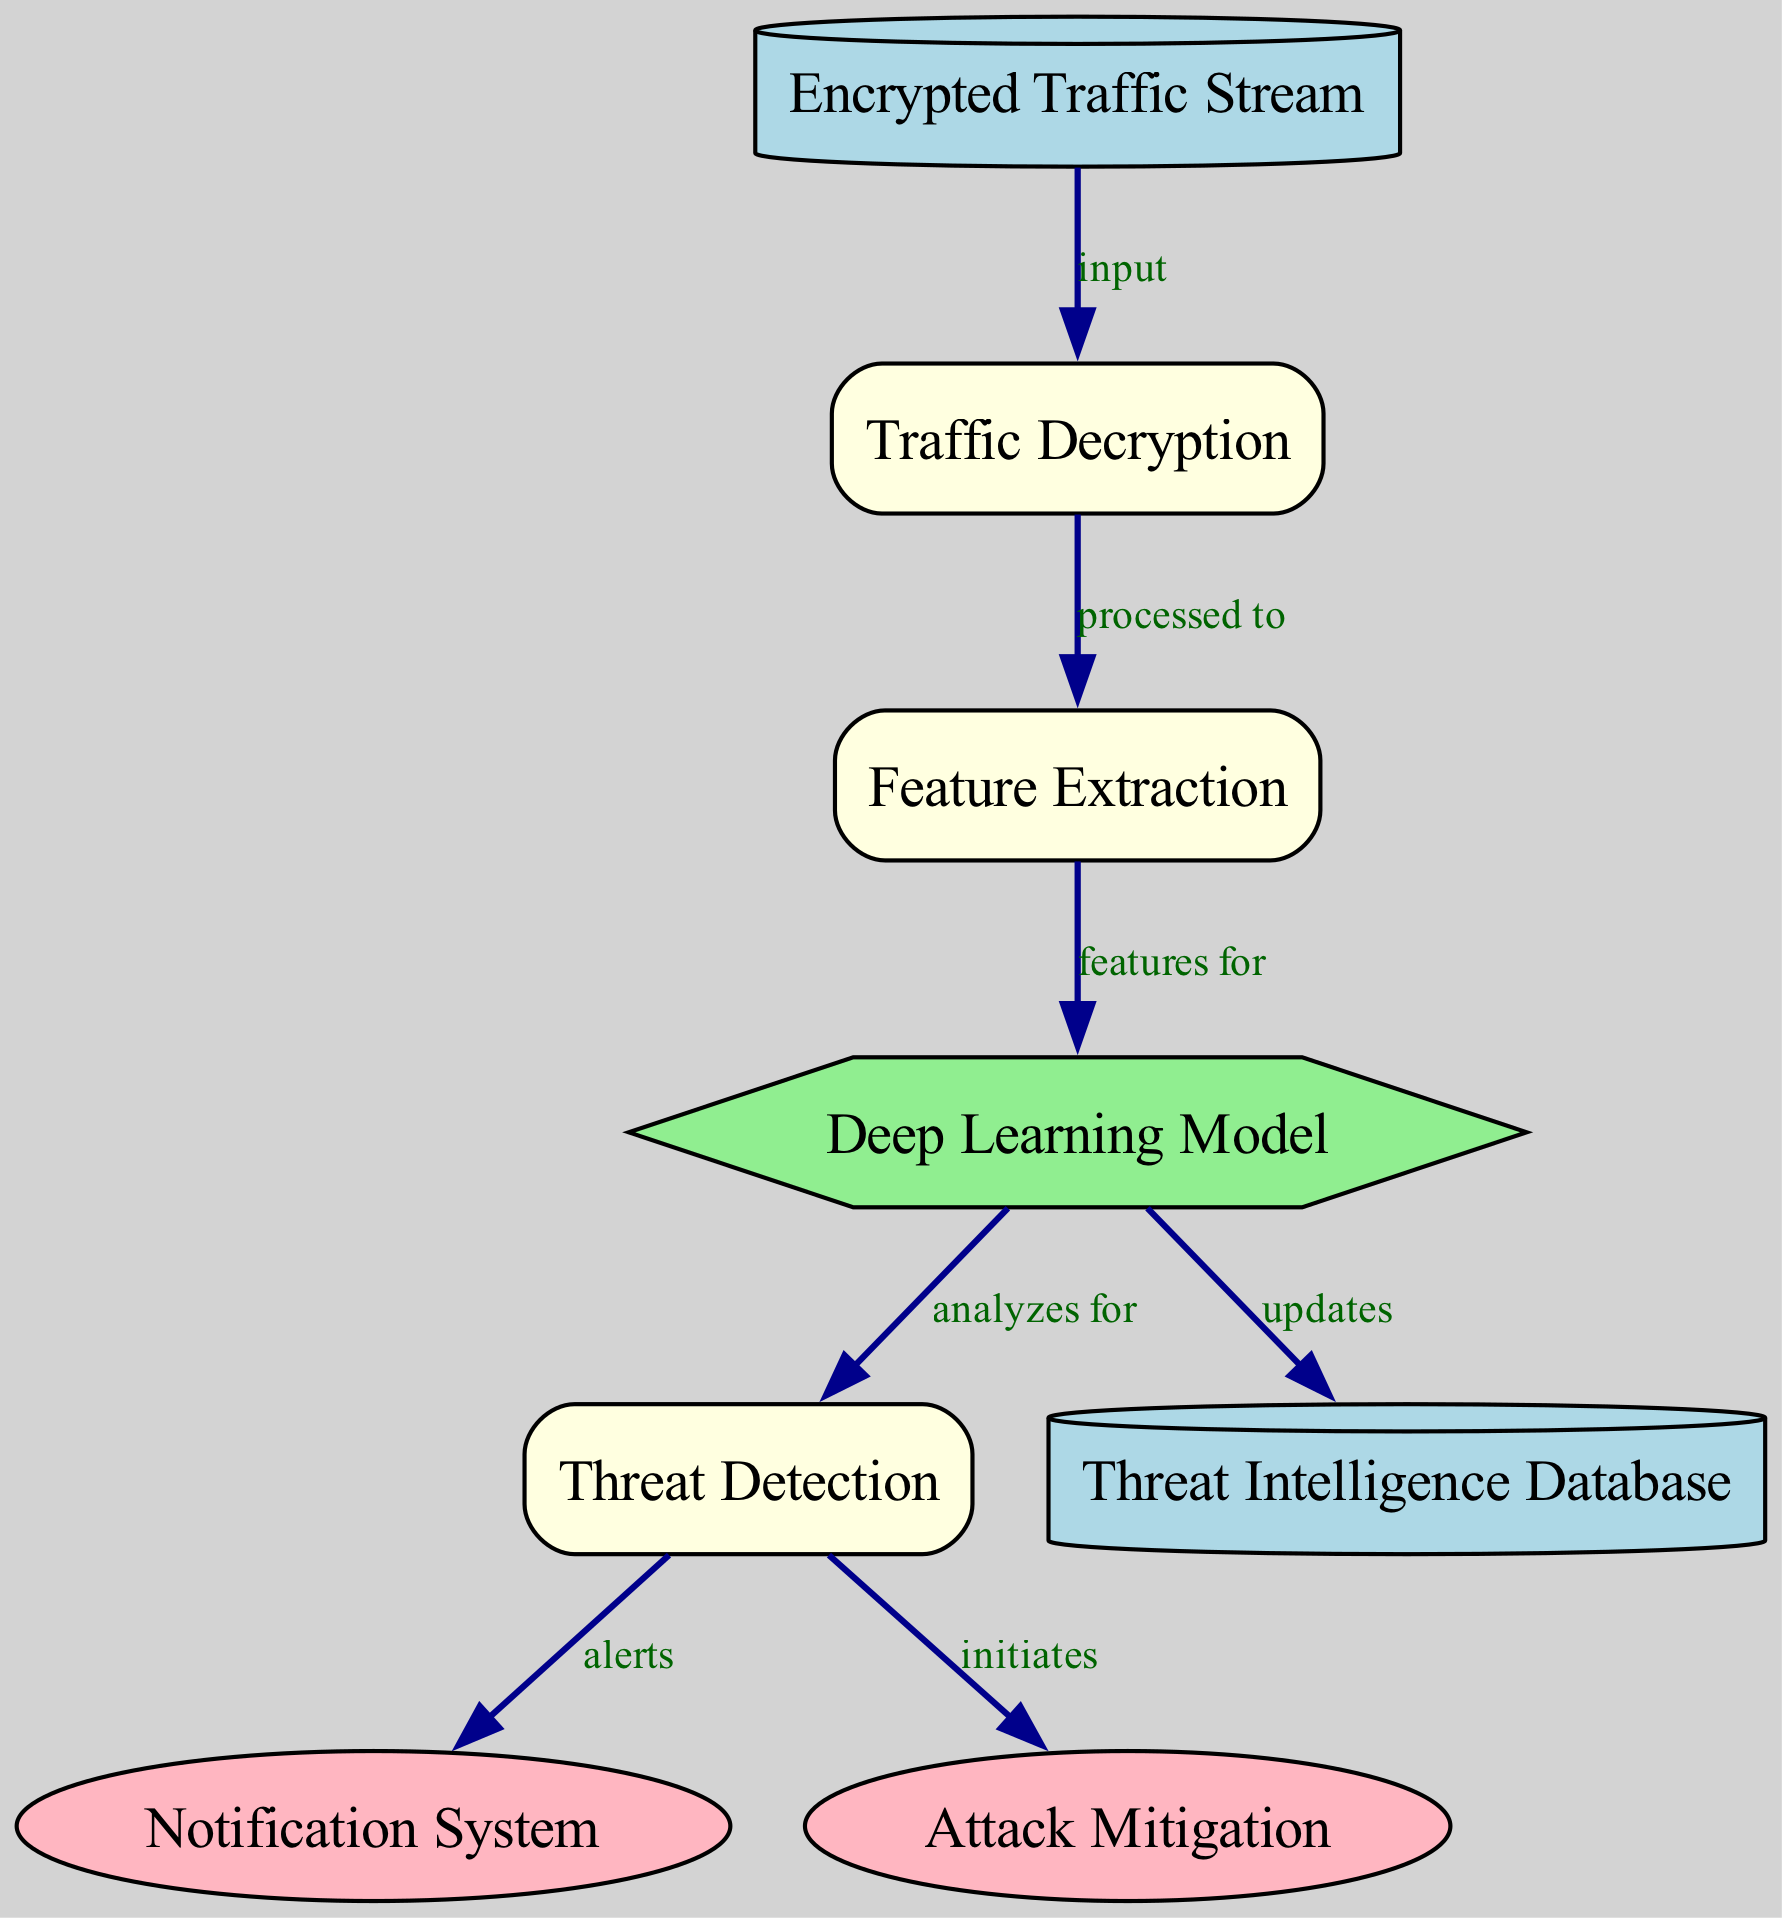What is the starting point of the diagram? The diagram starts with the node labeled "Encrypted Traffic Stream," which serves as the input data source for the process.
Answer: Encrypted Traffic Stream How many nodes are present in the diagram? By counting all the distinct nodes listed, we find there are a total of eight nodes depicted in the diagram.
Answer: 8 What type of node is "Deep Learning Model"? The node labeled "Deep Learning Model" is categorized as a model node within the document, and its type is indicated by its distinct shape and color in the diagram.
Answer: model What is the output of the "Threat Detection" process? The "Threat Detection" node has two outputs: it alerts the "Notification System" and initiates "Attack Mitigation," both illustrated by edges leading from it.
Answer: Notification System and Attack Mitigation Which node updates the "Threat Intelligence Database"? The "Deep Learning Model" is the node responsible for updating the "Threat Intelligence Database," as indicated by the directed edge from the model to the database.
Answer: Deep Learning Model What relationship does "Traffic Decryption" have with "Feature Extraction"? The "Traffic Decryption" node directly processes the input into the "Feature Extraction" node, as indicated by the labeled edge that describes their relationship in the diagram.
Answer: processed to What is required for "Threat Detection" to occur? "Threat Detection" relies on features extracted from the traffic data, which necessitates that data be decrypted and then analyzed by the deep learning model, establishing a sequential flow through the diagram.
Answer: features from Deep Learning Model What type of process is "Traffic Decryption"? "Traffic Decryption" is classified as a process node, evident from its box shape and filled color in the diagram which indicates its role in manipulating and transforming data.
Answer: process 